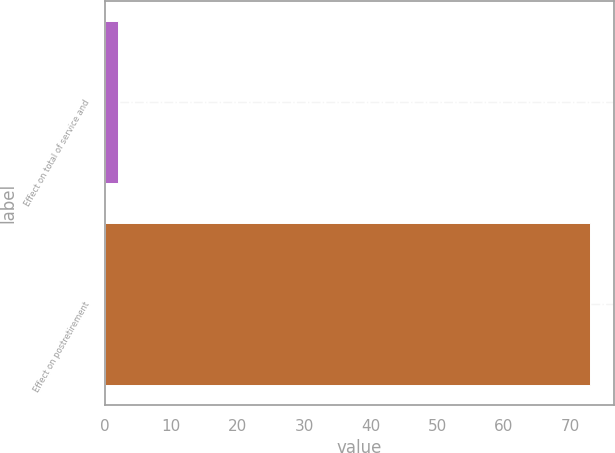Convert chart to OTSL. <chart><loc_0><loc_0><loc_500><loc_500><bar_chart><fcel>Effect on total of service and<fcel>Effect on postretirement<nl><fcel>2<fcel>73<nl></chart> 